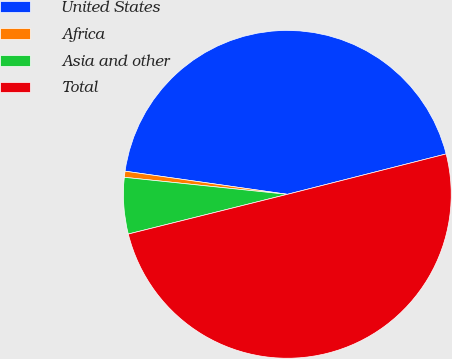<chart> <loc_0><loc_0><loc_500><loc_500><pie_chart><fcel>United States<fcel>Africa<fcel>Asia and other<fcel>Total<nl><fcel>43.78%<fcel>0.6%<fcel>5.55%<fcel>50.07%<nl></chart> 